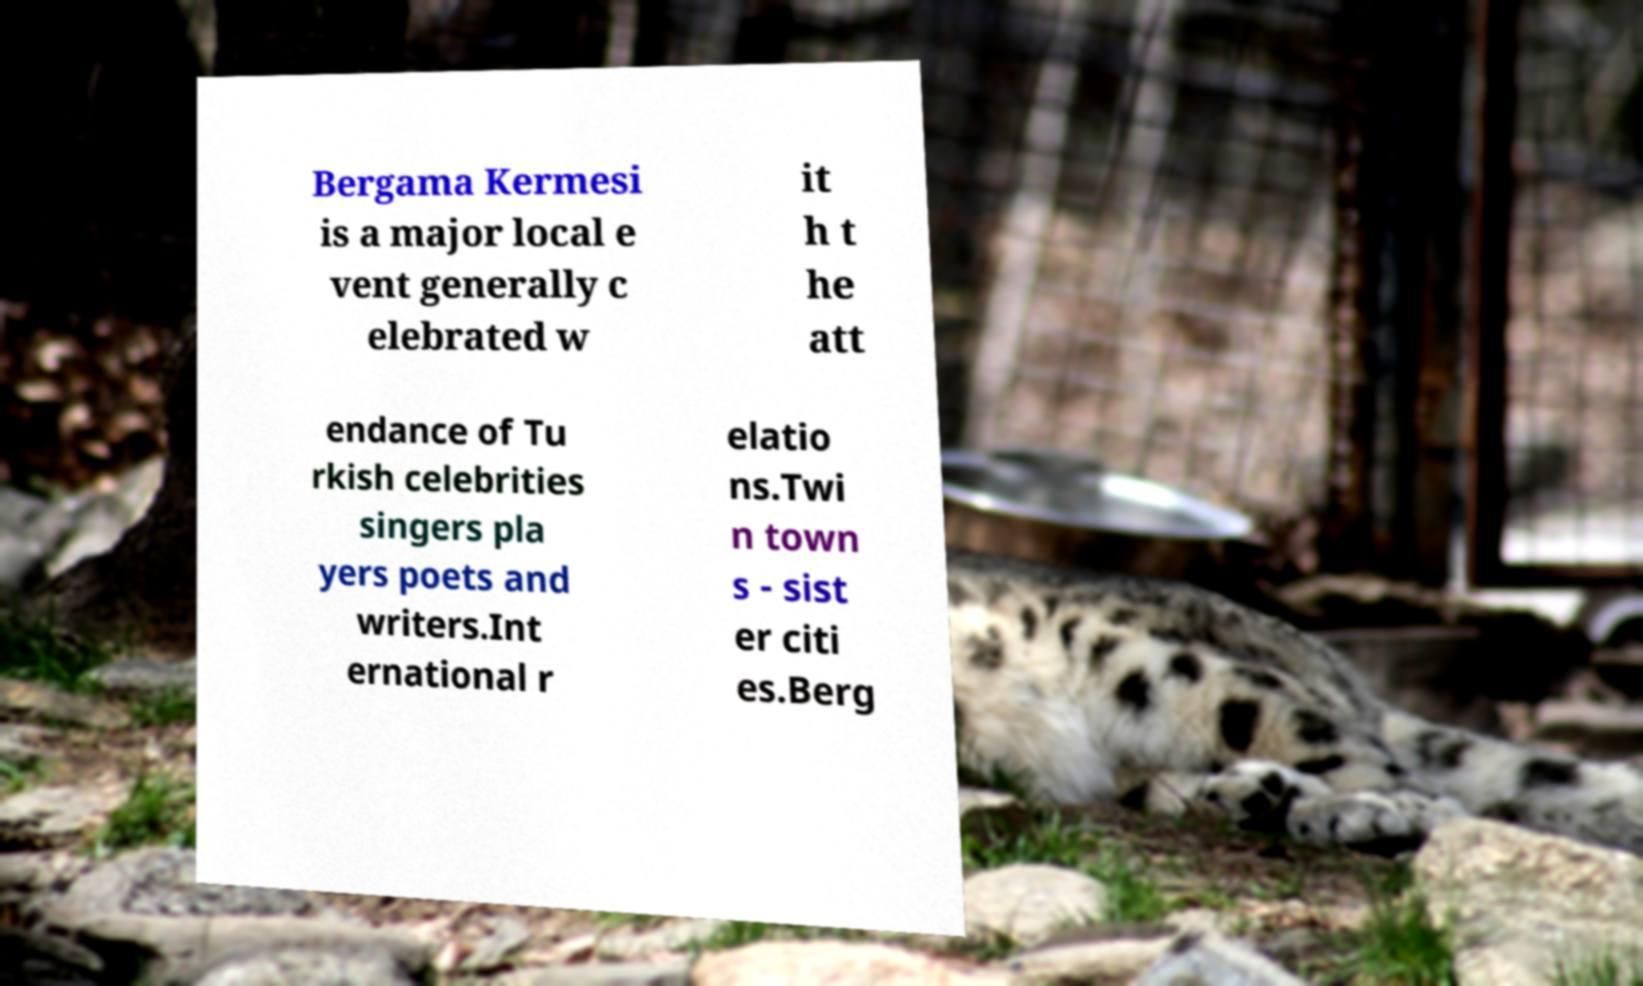What messages or text are displayed in this image? I need them in a readable, typed format. Bergama Kermesi is a major local e vent generally c elebrated w it h t he att endance of Tu rkish celebrities singers pla yers poets and writers.Int ernational r elatio ns.Twi n town s - sist er citi es.Berg 